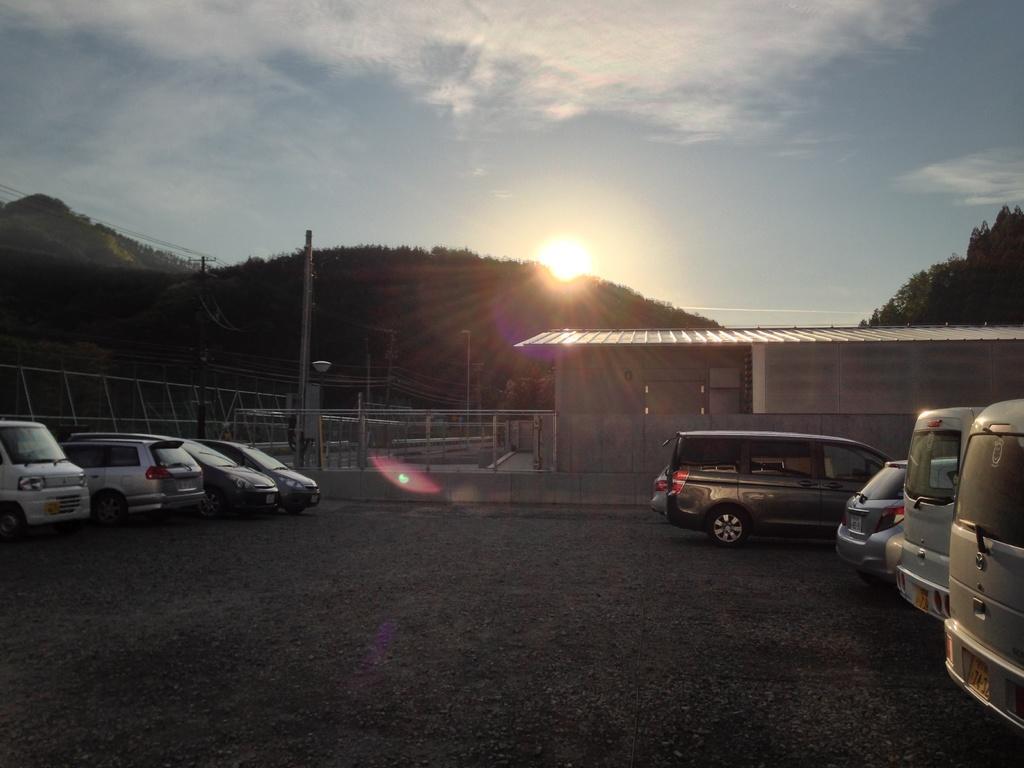Please provide a concise description of this image. In this image I can see many vehicles to the side of the shed. To the left I can see the railing. In the background I can see the trees, mountains, sun, clouds and the sky. 